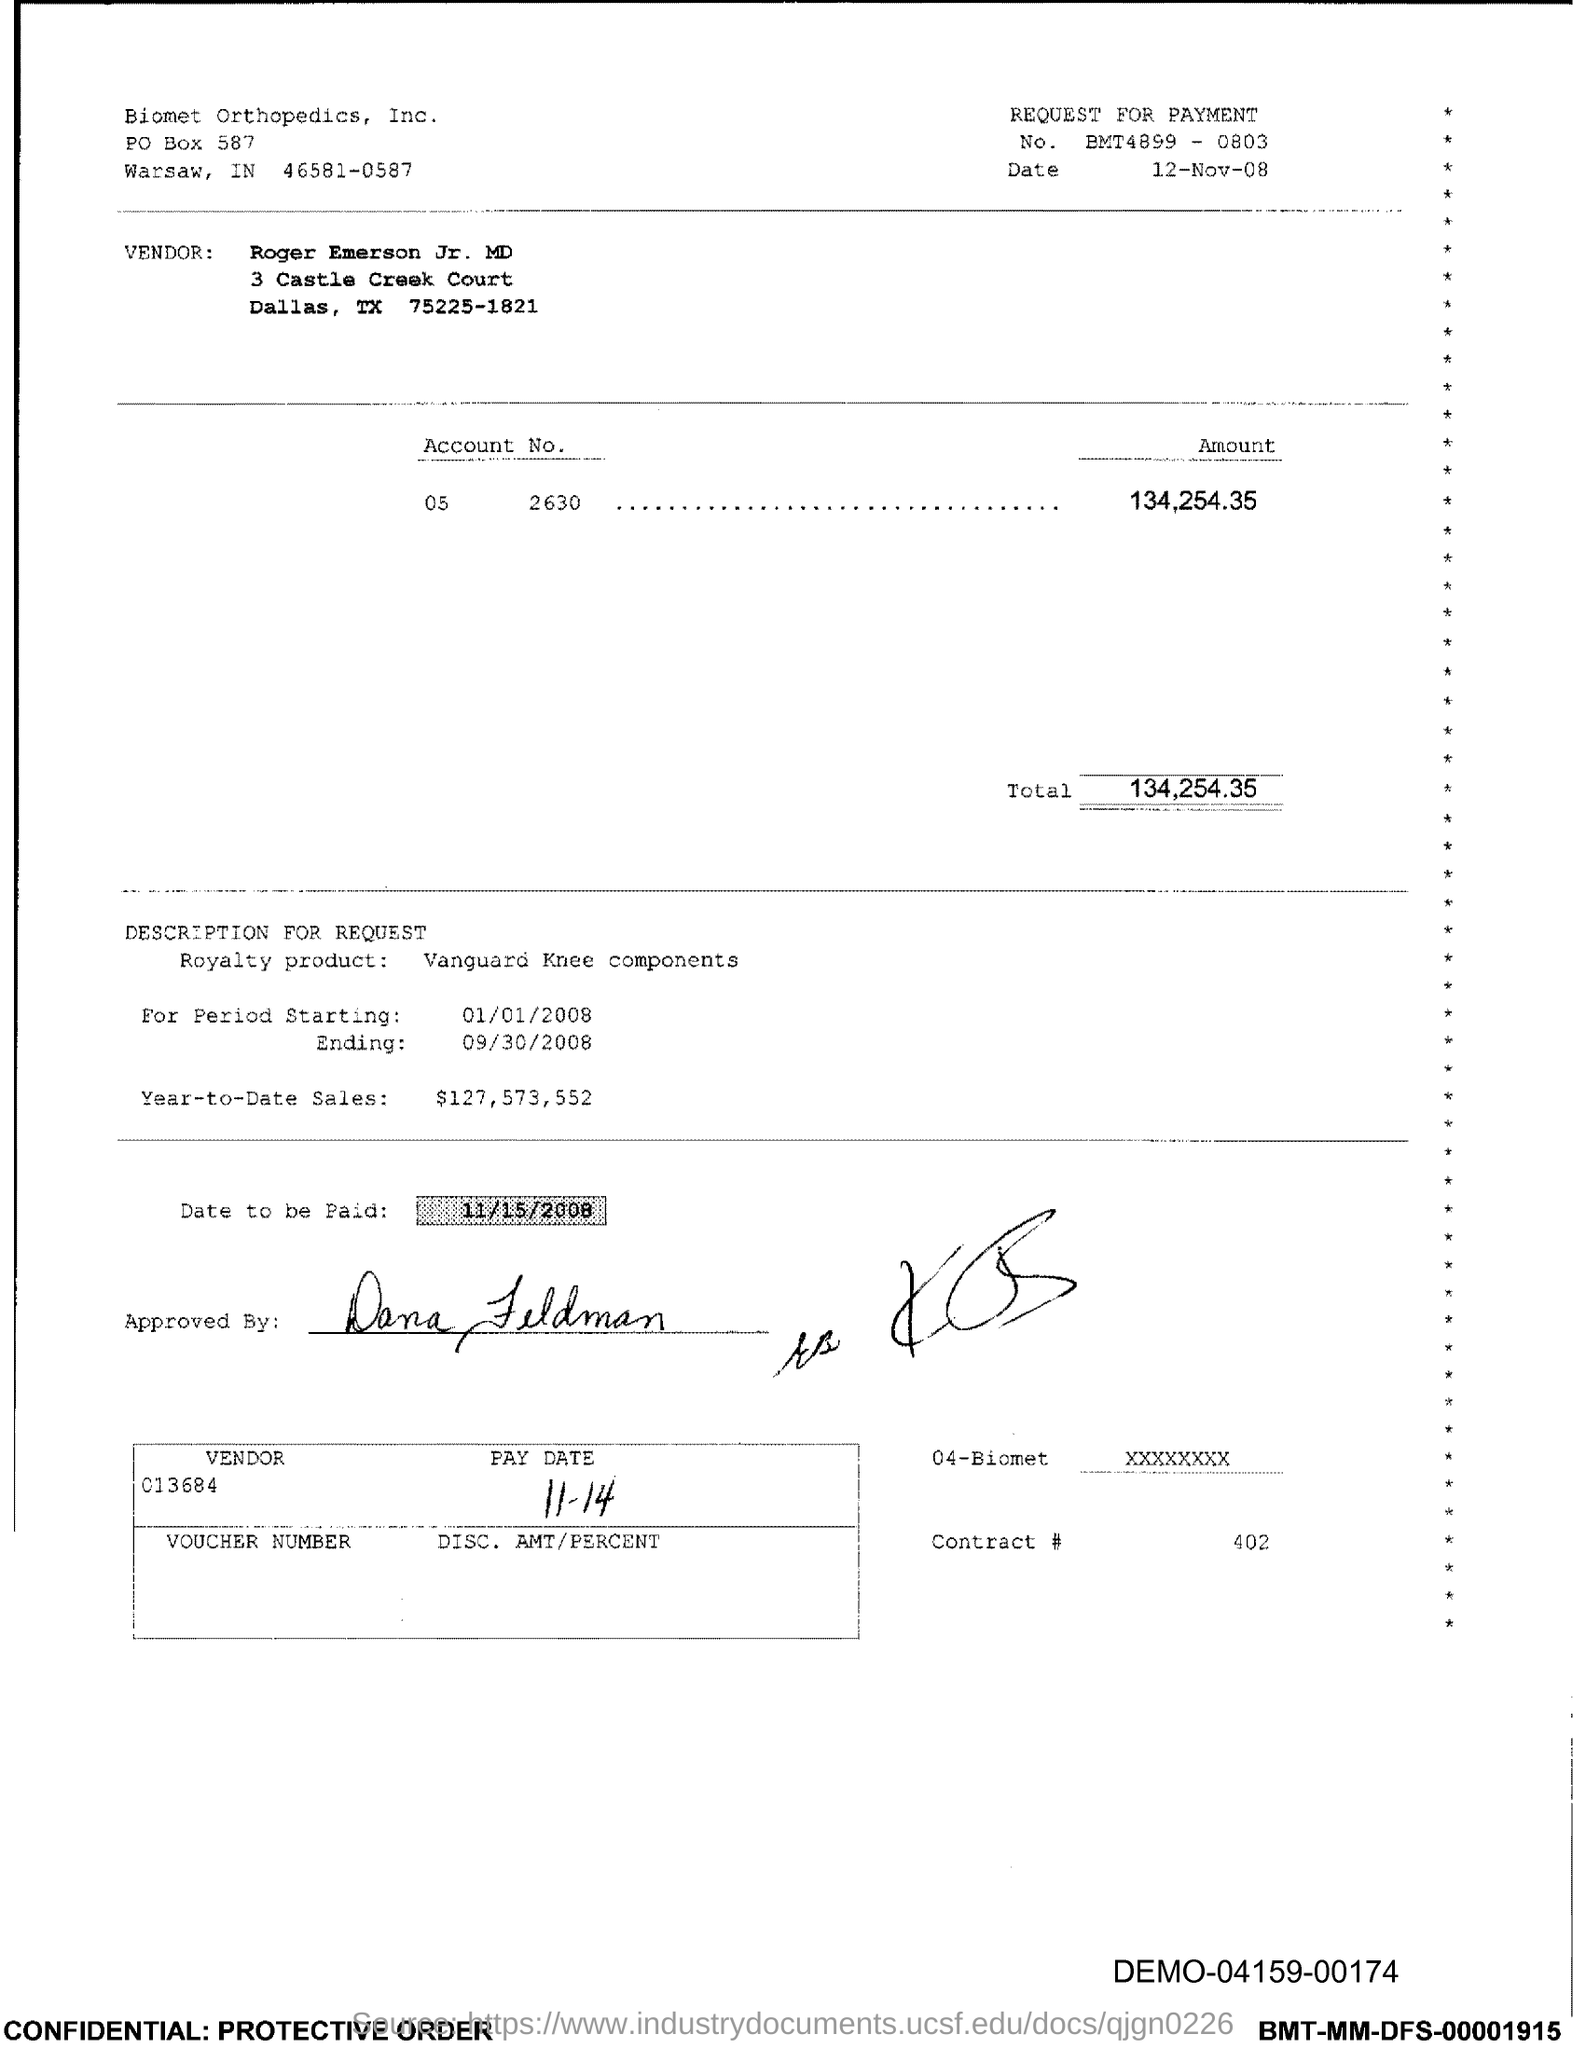Which company is mentioned in the header of the document?
Your answer should be compact. Biomet orthopedics. What is the issued date of this document?
Keep it short and to the point. 12-Nov-08. What is the Account No. given in the document?
Make the answer very short. 05 2630. What is the total amount to be paid as per the document?
Keep it short and to the point. 134,254.35. What is the royalty product mentioned in the document?
Ensure brevity in your answer.  Vanguard Knee components. What is the Year-to-Date Sales of the royalty product?
Offer a very short reply. $127,573,552. What is the date to be paid mentioned in the document?
Offer a very short reply. 11/15/2008. What is the contract # given in the document?
Provide a succinct answer. 402. 